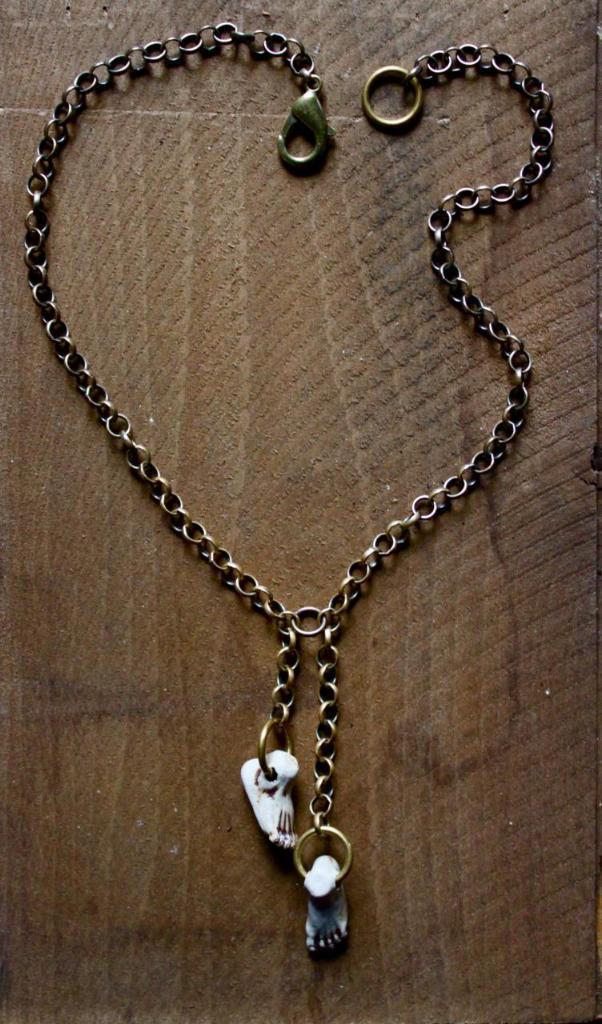Can you describe this image briefly? On this wooden surface there is a chain and dollar. 